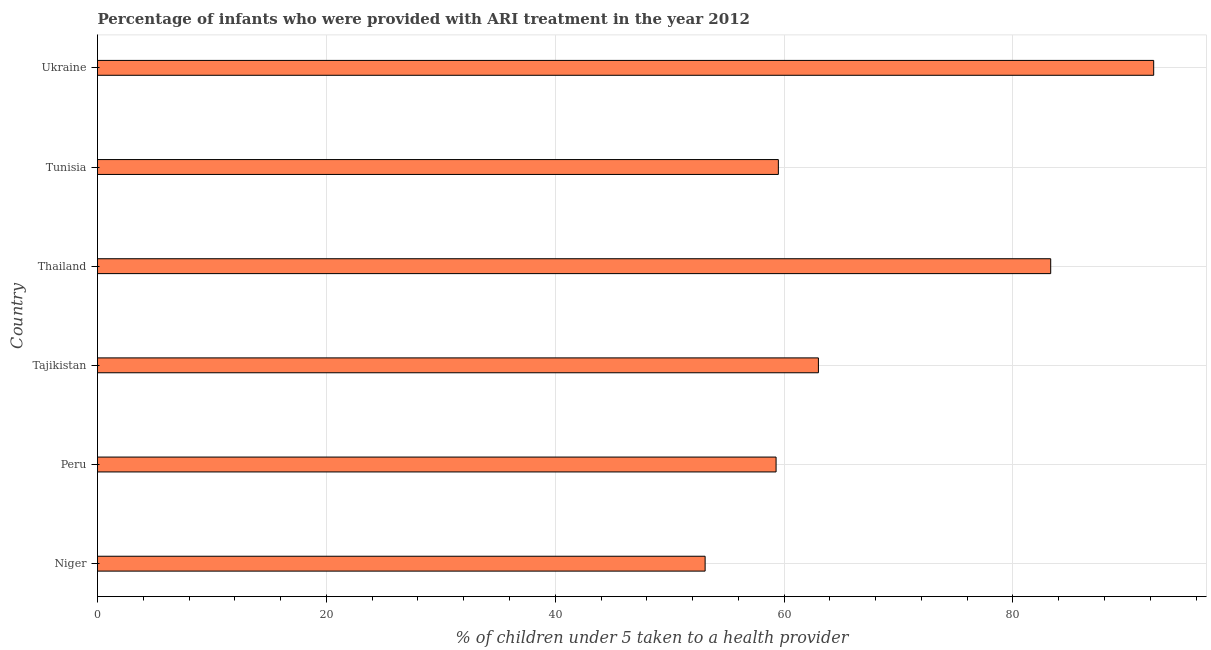Does the graph contain grids?
Provide a short and direct response. Yes. What is the title of the graph?
Your answer should be very brief. Percentage of infants who were provided with ARI treatment in the year 2012. What is the label or title of the X-axis?
Your answer should be compact. % of children under 5 taken to a health provider. What is the percentage of children who were provided with ari treatment in Niger?
Keep it short and to the point. 53.1. Across all countries, what is the maximum percentage of children who were provided with ari treatment?
Keep it short and to the point. 92.3. Across all countries, what is the minimum percentage of children who were provided with ari treatment?
Ensure brevity in your answer.  53.1. In which country was the percentage of children who were provided with ari treatment maximum?
Offer a very short reply. Ukraine. In which country was the percentage of children who were provided with ari treatment minimum?
Provide a succinct answer. Niger. What is the sum of the percentage of children who were provided with ari treatment?
Your response must be concise. 410.5. What is the difference between the percentage of children who were provided with ari treatment in Niger and Tunisia?
Offer a very short reply. -6.4. What is the average percentage of children who were provided with ari treatment per country?
Offer a very short reply. 68.42. What is the median percentage of children who were provided with ari treatment?
Keep it short and to the point. 61.25. What is the ratio of the percentage of children who were provided with ari treatment in Niger to that in Peru?
Provide a succinct answer. 0.9. Is the percentage of children who were provided with ari treatment in Tajikistan less than that in Tunisia?
Make the answer very short. No. Is the difference between the percentage of children who were provided with ari treatment in Tajikistan and Thailand greater than the difference between any two countries?
Ensure brevity in your answer.  No. Is the sum of the percentage of children who were provided with ari treatment in Niger and Thailand greater than the maximum percentage of children who were provided with ari treatment across all countries?
Your answer should be very brief. Yes. What is the difference between the highest and the lowest percentage of children who were provided with ari treatment?
Give a very brief answer. 39.2. In how many countries, is the percentage of children who were provided with ari treatment greater than the average percentage of children who were provided with ari treatment taken over all countries?
Offer a very short reply. 2. How many bars are there?
Offer a terse response. 6. What is the % of children under 5 taken to a health provider of Niger?
Ensure brevity in your answer.  53.1. What is the % of children under 5 taken to a health provider of Peru?
Ensure brevity in your answer.  59.3. What is the % of children under 5 taken to a health provider in Thailand?
Your answer should be very brief. 83.3. What is the % of children under 5 taken to a health provider in Tunisia?
Ensure brevity in your answer.  59.5. What is the % of children under 5 taken to a health provider of Ukraine?
Give a very brief answer. 92.3. What is the difference between the % of children under 5 taken to a health provider in Niger and Peru?
Provide a short and direct response. -6.2. What is the difference between the % of children under 5 taken to a health provider in Niger and Thailand?
Your response must be concise. -30.2. What is the difference between the % of children under 5 taken to a health provider in Niger and Tunisia?
Your response must be concise. -6.4. What is the difference between the % of children under 5 taken to a health provider in Niger and Ukraine?
Keep it short and to the point. -39.2. What is the difference between the % of children under 5 taken to a health provider in Peru and Tajikistan?
Give a very brief answer. -3.7. What is the difference between the % of children under 5 taken to a health provider in Peru and Ukraine?
Provide a short and direct response. -33. What is the difference between the % of children under 5 taken to a health provider in Tajikistan and Thailand?
Provide a succinct answer. -20.3. What is the difference between the % of children under 5 taken to a health provider in Tajikistan and Tunisia?
Provide a succinct answer. 3.5. What is the difference between the % of children under 5 taken to a health provider in Tajikistan and Ukraine?
Provide a short and direct response. -29.3. What is the difference between the % of children under 5 taken to a health provider in Thailand and Tunisia?
Ensure brevity in your answer.  23.8. What is the difference between the % of children under 5 taken to a health provider in Thailand and Ukraine?
Offer a very short reply. -9. What is the difference between the % of children under 5 taken to a health provider in Tunisia and Ukraine?
Give a very brief answer. -32.8. What is the ratio of the % of children under 5 taken to a health provider in Niger to that in Peru?
Offer a very short reply. 0.9. What is the ratio of the % of children under 5 taken to a health provider in Niger to that in Tajikistan?
Make the answer very short. 0.84. What is the ratio of the % of children under 5 taken to a health provider in Niger to that in Thailand?
Keep it short and to the point. 0.64. What is the ratio of the % of children under 5 taken to a health provider in Niger to that in Tunisia?
Provide a short and direct response. 0.89. What is the ratio of the % of children under 5 taken to a health provider in Niger to that in Ukraine?
Ensure brevity in your answer.  0.57. What is the ratio of the % of children under 5 taken to a health provider in Peru to that in Tajikistan?
Your answer should be very brief. 0.94. What is the ratio of the % of children under 5 taken to a health provider in Peru to that in Thailand?
Give a very brief answer. 0.71. What is the ratio of the % of children under 5 taken to a health provider in Peru to that in Tunisia?
Make the answer very short. 1. What is the ratio of the % of children under 5 taken to a health provider in Peru to that in Ukraine?
Offer a very short reply. 0.64. What is the ratio of the % of children under 5 taken to a health provider in Tajikistan to that in Thailand?
Offer a very short reply. 0.76. What is the ratio of the % of children under 5 taken to a health provider in Tajikistan to that in Tunisia?
Make the answer very short. 1.06. What is the ratio of the % of children under 5 taken to a health provider in Tajikistan to that in Ukraine?
Ensure brevity in your answer.  0.68. What is the ratio of the % of children under 5 taken to a health provider in Thailand to that in Tunisia?
Ensure brevity in your answer.  1.4. What is the ratio of the % of children under 5 taken to a health provider in Thailand to that in Ukraine?
Your response must be concise. 0.9. What is the ratio of the % of children under 5 taken to a health provider in Tunisia to that in Ukraine?
Provide a succinct answer. 0.65. 